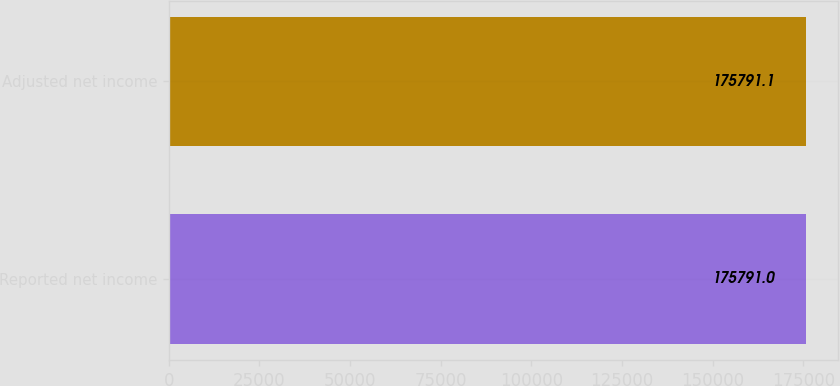<chart> <loc_0><loc_0><loc_500><loc_500><bar_chart><fcel>Reported net income<fcel>Adjusted net income<nl><fcel>175791<fcel>175791<nl></chart> 